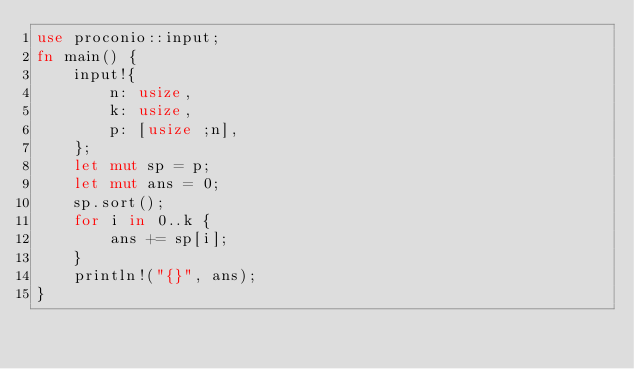<code> <loc_0><loc_0><loc_500><loc_500><_Rust_>use proconio::input;
fn main() {
    input!{
        n: usize,
        k: usize,
        p: [usize ;n],
    };
    let mut sp = p;
    let mut ans = 0;
    sp.sort();
    for i in 0..k {
        ans += sp[i];
    }
    println!("{}", ans);
}</code> 